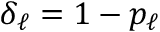<formula> <loc_0><loc_0><loc_500><loc_500>\delta _ { \ell } = 1 - p _ { \ell }</formula> 